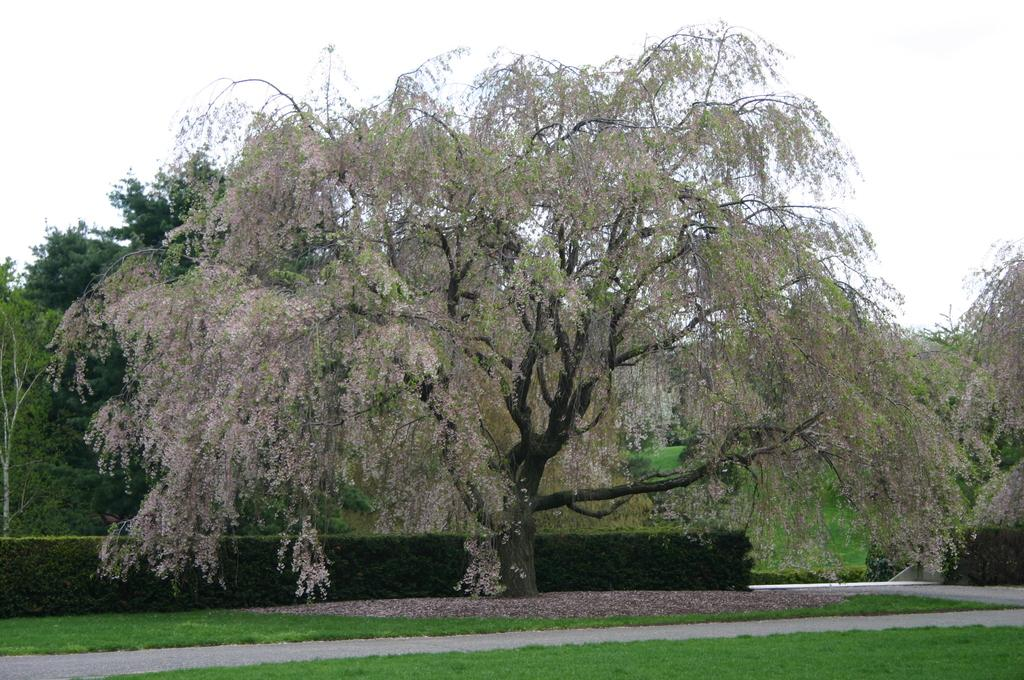What type of vegetation can be seen in the image? There are trees and bushes in the image. What is at the bottom of the image? There is grass and a pathway at the bottom of the image. What can be seen in the background of the image? The sky is visible in the background of the image. How many bikes are running along the pathway in the image? There are no bikes or running activities depicted in the image. 